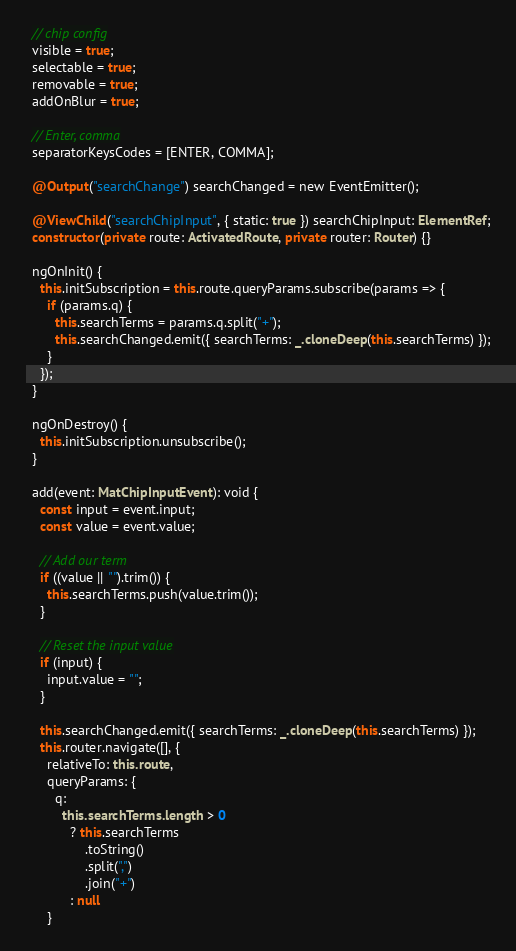<code> <loc_0><loc_0><loc_500><loc_500><_TypeScript_>  // chip config
  visible = true;
  selectable = true;
  removable = true;
  addOnBlur = true;

  // Enter, comma
  separatorKeysCodes = [ENTER, COMMA];

  @Output("searchChange") searchChanged = new EventEmitter();

  @ViewChild("searchChipInput", { static: true }) searchChipInput: ElementRef;
  constructor(private route: ActivatedRoute, private router: Router) {}

  ngOnInit() {
    this.initSubscription = this.route.queryParams.subscribe(params => {
      if (params.q) {
        this.searchTerms = params.q.split("+");
        this.searchChanged.emit({ searchTerms: _.cloneDeep(this.searchTerms) });
      }
    });
  }

  ngOnDestroy() {
    this.initSubscription.unsubscribe();
  }

  add(event: MatChipInputEvent): void {
    const input = event.input;
    const value = event.value;

    // Add our term
    if ((value || "").trim()) {
      this.searchTerms.push(value.trim());
    }

    // Reset the input value
    if (input) {
      input.value = "";
    }

    this.searchChanged.emit({ searchTerms: _.cloneDeep(this.searchTerms) });
    this.router.navigate([], {
      relativeTo: this.route,
      queryParams: {
        q:
          this.searchTerms.length > 0
            ? this.searchTerms
                .toString()
                .split(",")
                .join("+")
            : null
      }</code> 